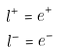Convert formula to latex. <formula><loc_0><loc_0><loc_500><loc_500>l ^ { + } & = e ^ { + } \\ l ^ { - } & = e ^ { - }</formula> 